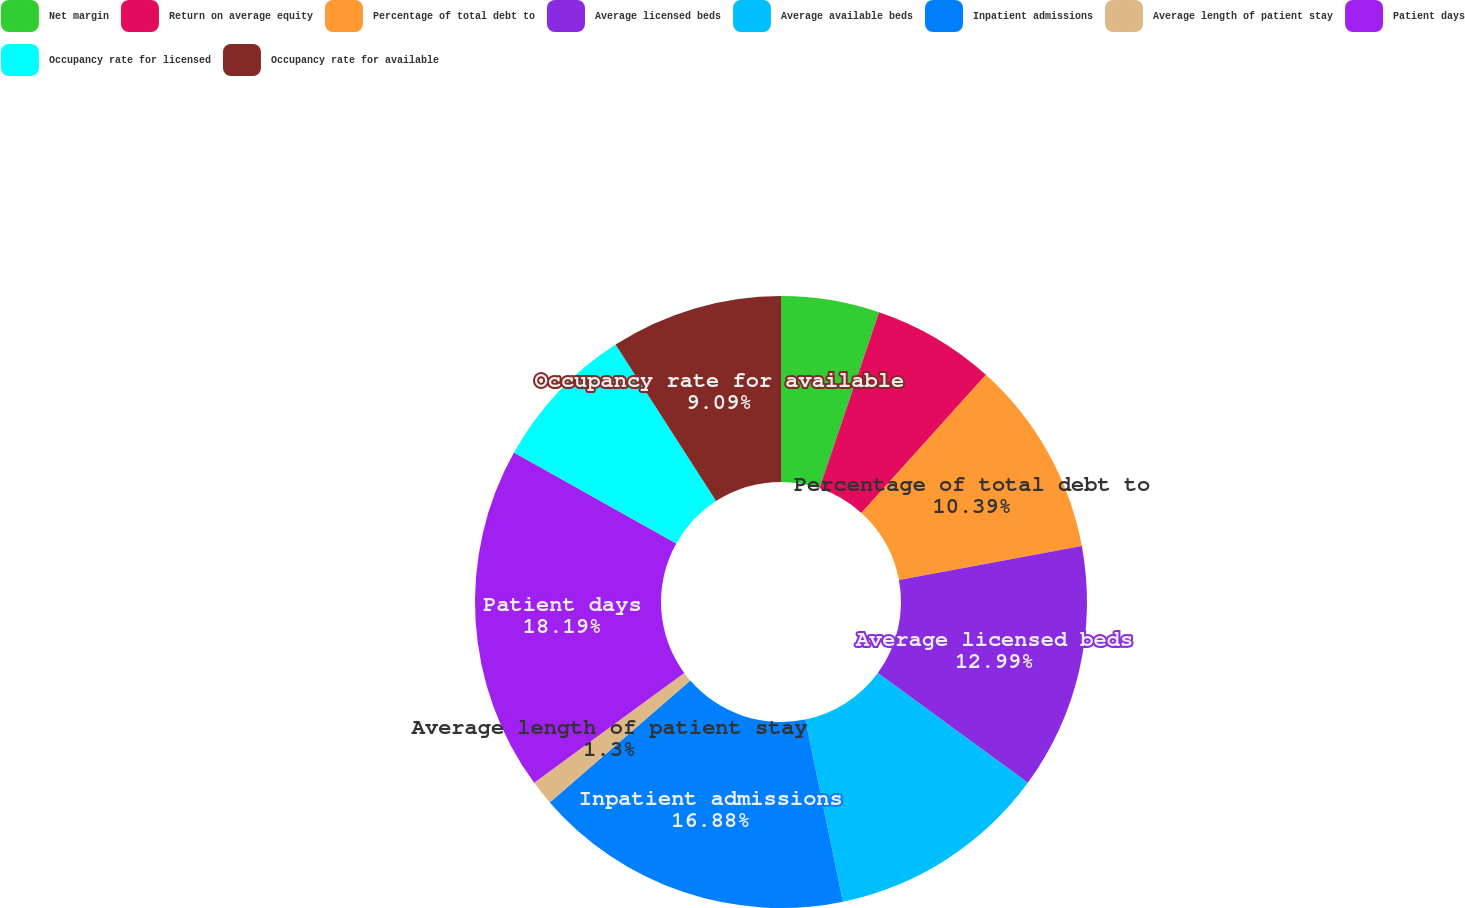<chart> <loc_0><loc_0><loc_500><loc_500><pie_chart><fcel>Net margin<fcel>Return on average equity<fcel>Percentage of total debt to<fcel>Average licensed beds<fcel>Average available beds<fcel>Inpatient admissions<fcel>Average length of patient stay<fcel>Patient days<fcel>Occupancy rate for licensed<fcel>Occupancy rate for available<nl><fcel>5.19%<fcel>6.49%<fcel>10.39%<fcel>12.99%<fcel>11.69%<fcel>16.88%<fcel>1.3%<fcel>18.18%<fcel>7.79%<fcel>9.09%<nl></chart> 